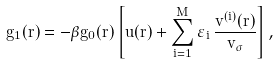<formula> <loc_0><loc_0><loc_500><loc_500>g _ { 1 } ( r ) = - \beta g _ { 0 } ( r ) \left [ u ( r ) + \sum _ { i = 1 } ^ { M } \varepsilon _ { i } \, \frac { v ^ { ( i ) } ( r ) } { v _ { \sigma } } \right ] ,</formula> 